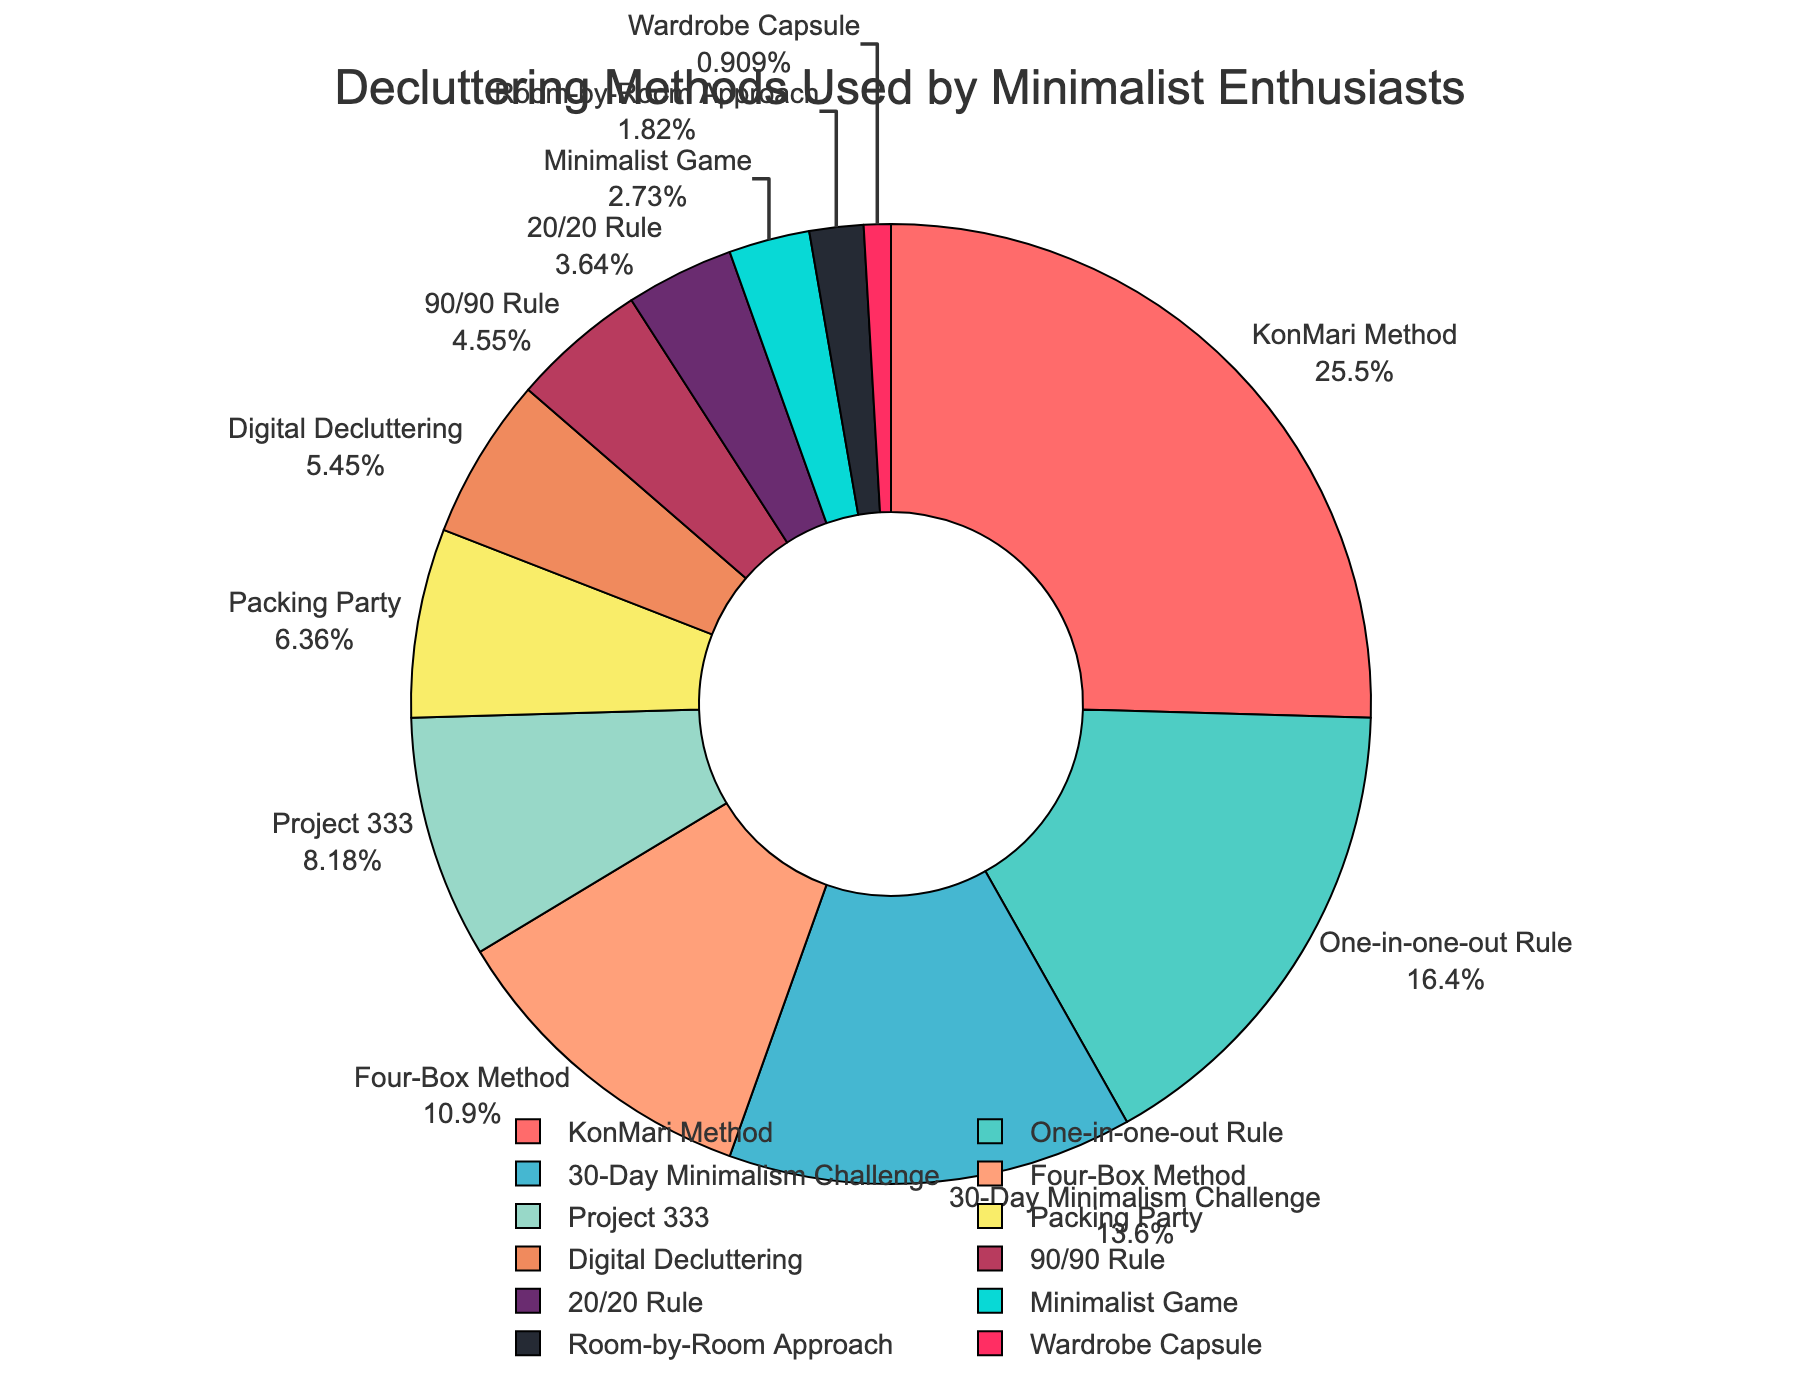What's the most used decluttering method according to the pie chart? The KonMari Method occupies the largest section of the pie chart, indicating it has the highest percentage.
Answer: The KonMari Method Which decluttering method has the smallest share? The smallest section of the pie chart corresponds to the Wardrobe Capsule method.
Answer: Wardrobe Capsule What percentage of minimalist enthusiasts use the KonMari Method and the One-in-one-out Rule combined? The KonMari Method is used by 28% and the One-in-one-out Rule by 18%. Adding these: 28% + 18% = 46%
Answer: 46% How does the share of the 30-Day Minimalism Challenge compare to the 90/90 Rule? The 30-Day Minimalism Challenge has a larger share at 15%, compared to the 90/90 Rule which has 5%.
Answer: The 30-Day Minimalism Challenge has 10% more Which methods together account for approximately half of the total share? The methods with the highest shares are the KonMari Method (28%) and the One-in-one-out Rule (18%). Adding these gives 28% + 18% = 46%, which is close to half.
Answer: KonMari Method and One-in-one-out Rule Is Digital Decluttering used more or less than Project 333? Digital Decluttering has a share of 6%, while Project 333 has 9%.
Answer: Less What is the combined percentage for the Four-Box Method, Packing Party, and Minimalist Game? The Four-Box Method is 12%, Packing Party is 7%, and Minimalist Game is 3%. Adding these: 12% + 7% + 3% = 22%
Answer: 22% How does the share of the 20/20 Rule compare to that of Room-by-Room Approach? The 20/20 Rule has a larger share at 4%, compared to the Room-by-Room Approach which has 2%.
Answer: The 20/20 Rule is 2% more Which decluttering method is represented by the color red? The color coding for red shows it corresponds to the KonMari Method.
Answer: The KonMari Method 